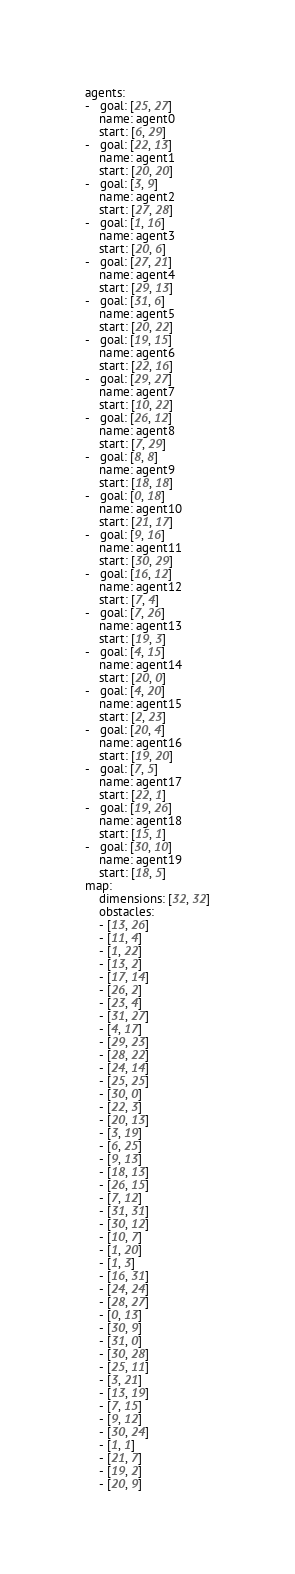Convert code to text. <code><loc_0><loc_0><loc_500><loc_500><_YAML_>agents:
-   goal: [25, 27]
    name: agent0
    start: [6, 29]
-   goal: [22, 13]
    name: agent1
    start: [20, 20]
-   goal: [3, 9]
    name: agent2
    start: [27, 28]
-   goal: [1, 16]
    name: agent3
    start: [20, 6]
-   goal: [27, 21]
    name: agent4
    start: [29, 13]
-   goal: [31, 6]
    name: agent5
    start: [20, 22]
-   goal: [19, 15]
    name: agent6
    start: [22, 16]
-   goal: [29, 27]
    name: agent7
    start: [10, 22]
-   goal: [26, 12]
    name: agent8
    start: [7, 29]
-   goal: [8, 8]
    name: agent9
    start: [18, 18]
-   goal: [0, 18]
    name: agent10
    start: [21, 17]
-   goal: [9, 16]
    name: agent11
    start: [30, 29]
-   goal: [16, 12]
    name: agent12
    start: [7, 4]
-   goal: [7, 26]
    name: agent13
    start: [19, 3]
-   goal: [4, 15]
    name: agent14
    start: [20, 0]
-   goal: [4, 20]
    name: agent15
    start: [2, 23]
-   goal: [20, 4]
    name: agent16
    start: [19, 20]
-   goal: [7, 5]
    name: agent17
    start: [22, 1]
-   goal: [19, 26]
    name: agent18
    start: [15, 1]
-   goal: [30, 10]
    name: agent19
    start: [18, 5]
map:
    dimensions: [32, 32]
    obstacles:
    - [13, 26]
    - [11, 4]
    - [1, 22]
    - [13, 2]
    - [17, 14]
    - [26, 2]
    - [23, 4]
    - [31, 27]
    - [4, 17]
    - [29, 23]
    - [28, 22]
    - [24, 14]
    - [25, 25]
    - [30, 0]
    - [22, 3]
    - [20, 13]
    - [3, 19]
    - [6, 25]
    - [9, 13]
    - [18, 13]
    - [26, 15]
    - [7, 12]
    - [31, 31]
    - [30, 12]
    - [10, 7]
    - [1, 20]
    - [1, 3]
    - [16, 31]
    - [24, 24]
    - [28, 27]
    - [0, 13]
    - [30, 9]
    - [31, 0]
    - [30, 28]
    - [25, 11]
    - [3, 21]
    - [13, 19]
    - [7, 15]
    - [9, 12]
    - [30, 24]
    - [1, 1]
    - [21, 7]
    - [19, 2]
    - [20, 9]</code> 